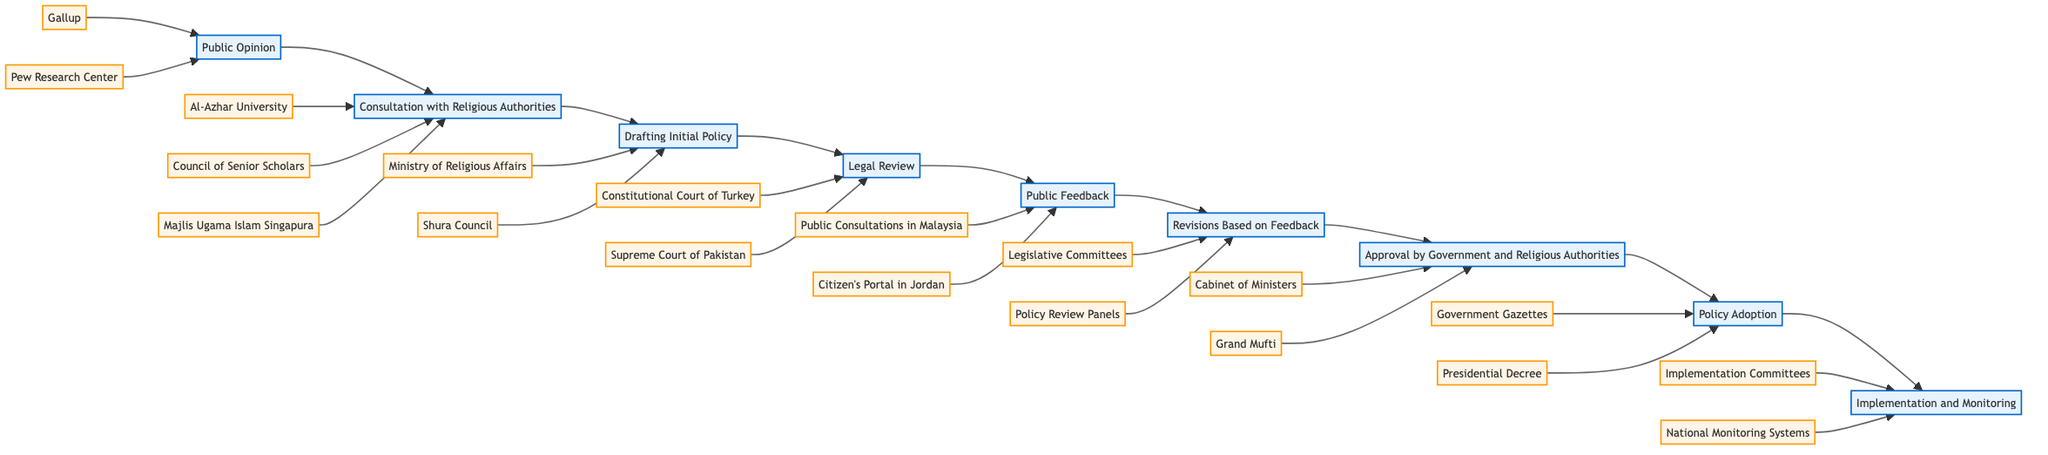What is the first step in the flowchart? The first step is "Public Opinion". It is the starting point of the flowchart, indicating that gathering public opinions is where the process begins.
Answer: Public Opinion How many entities are involved in the "Consultation with Religious Authorities" step? The "Consultation with Religious Authorities" step has three associated entities: Al-Azhar University, Council of Senior Scholars in Saudi Arabia, and Majlis Ugama Islam Singapura.
Answer: 3 What follows the "Drafting Initial Policy" step? The step that follows "Drafting Initial Policy" is "Legal Review". This indicates the sequential flow of the process.
Answer: Legal Review Which two entities are involved in the "Legal Review" step? The entities involved in the "Legal Review" step are the Constitutional Court of Turkey and the Supreme Court of Pakistan. This is confirmed by looking at the entities that point to this step.
Answer: Constitutional Court of Turkey, Supreme Court of Pakistan What is the last step in the flowchart? The last step is "Implementation and Monitoring". This signifies the final phase where the policy is executed and its impact is observed.
Answer: Implementation and Monitoring What step comes before "Approval by Government and Religious Authorities"? The step that comes before "Approval by Government and Religious Authorities" is "Revisions Based on Feedback". This indicates the necessary adjustments made to the draft prior to final approval.
Answer: Revisions Based on Feedback How many total steps are in the flowchart? There are eight steps in total within the flowchart, each representing a stage in the process from public consultation to policy adoption.
Answer: 8 Which public feedback methods are mentioned in the flowchart? The methods mentioned for public feedback are Public Consultations in Malaysia and Citizen's Portal in Jordan, as both are specified in the "Public Feedback" step.
Answer: Public Consultations in Malaysia, Citizen's Portal in Jordan 